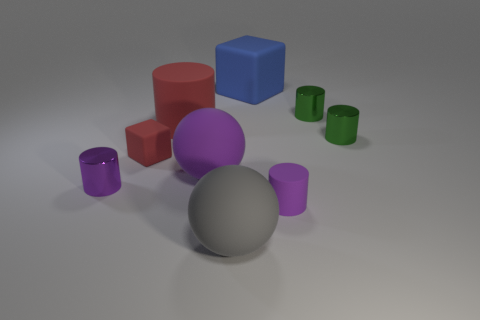Subtract all big cylinders. How many cylinders are left? 4 Add 1 tiny purple matte cylinders. How many objects exist? 10 Subtract all cylinders. How many objects are left? 4 Subtract 0 green spheres. How many objects are left? 9 Subtract 4 cylinders. How many cylinders are left? 1 Subtract all cyan cylinders. Subtract all gray cubes. How many cylinders are left? 5 Subtract all yellow cylinders. How many red balls are left? 0 Subtract all big red cylinders. Subtract all small blocks. How many objects are left? 7 Add 7 tiny rubber objects. How many tiny rubber objects are left? 9 Add 9 big yellow blocks. How many big yellow blocks exist? 9 